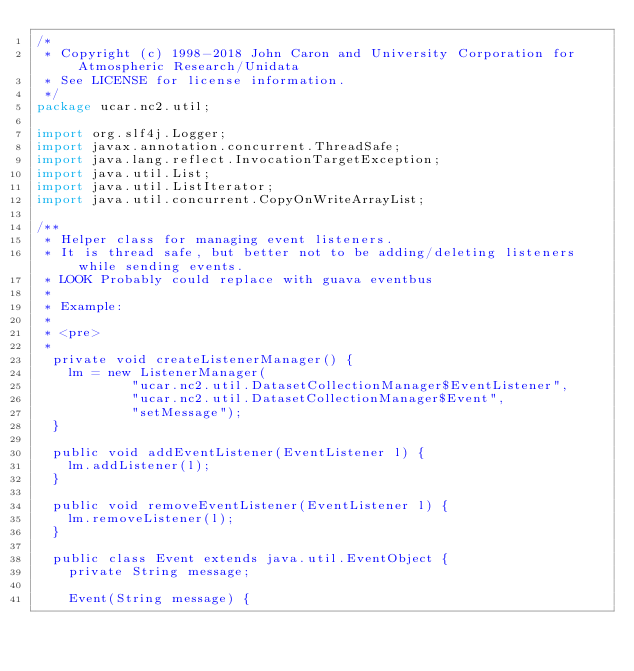<code> <loc_0><loc_0><loc_500><loc_500><_Java_>/*
 * Copyright (c) 1998-2018 John Caron and University Corporation for Atmospheric Research/Unidata
 * See LICENSE for license information.
 */
package ucar.nc2.util;

import org.slf4j.Logger;
import javax.annotation.concurrent.ThreadSafe;
import java.lang.reflect.InvocationTargetException;
import java.util.List;
import java.util.ListIterator;
import java.util.concurrent.CopyOnWriteArrayList;

/**
 * Helper class for managing event listeners.
 * It is thread safe, but better not to be adding/deleting listeners while sending events.
 * LOOK Probably could replace with guava eventbus
 *
 * Example:
 * 
 * <pre>
 *
  private void createListenerManager() {
    lm = new ListenerManager(
            "ucar.nc2.util.DatasetCollectionManager$EventListener",
            "ucar.nc2.util.DatasetCollectionManager$Event",
            "setMessage");
  }

  public void addEventListener(EventListener l) {
    lm.addListener(l);
  }

  public void removeEventListener(EventListener l) {
    lm.removeListener(l);
  }

  public class Event extends java.util.EventObject {
    private String message;

    Event(String message) {</code> 